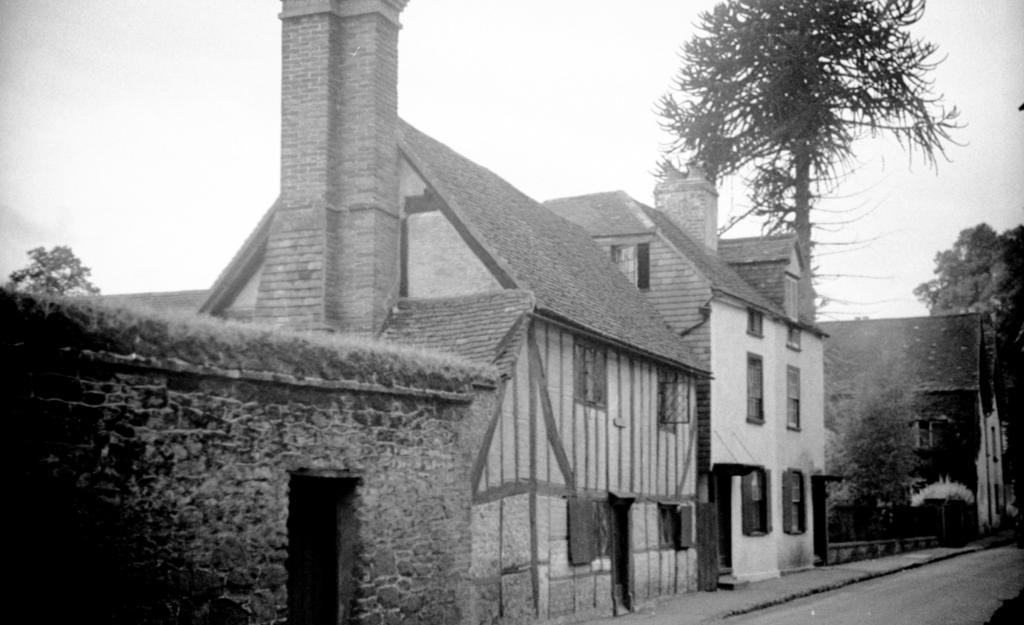What type of structures are present in the image? There are houses in the image. What type of vegetation can be seen in the image? There are trees and plants in the image. What type of barrier is present in the image? There is a fence in the image. What part of the natural environment is visible in the image? The sky is visible in the image. Where is the doctor standing in the image? There is no doctor present in the image. What type of hall can be seen in the image? There is no hall present in the image. 